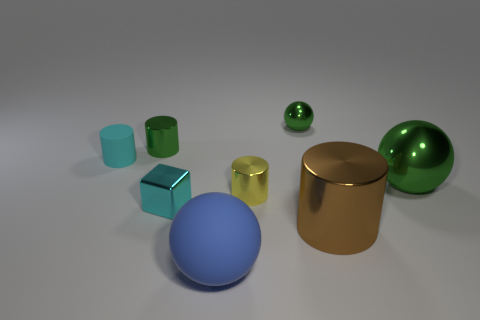Subtract all large green metal balls. How many balls are left? 2 Subtract all green cylinders. How many cylinders are left? 3 Subtract all blocks. How many objects are left? 7 Subtract 1 cylinders. How many cylinders are left? 3 Add 5 cyan shiny cubes. How many cyan shiny cubes are left? 6 Add 1 small green shiny spheres. How many small green shiny spheres exist? 2 Add 1 yellow cylinders. How many objects exist? 9 Subtract 0 green blocks. How many objects are left? 8 Subtract all red cubes. Subtract all green cylinders. How many cubes are left? 1 Subtract all blue cubes. How many red spheres are left? 0 